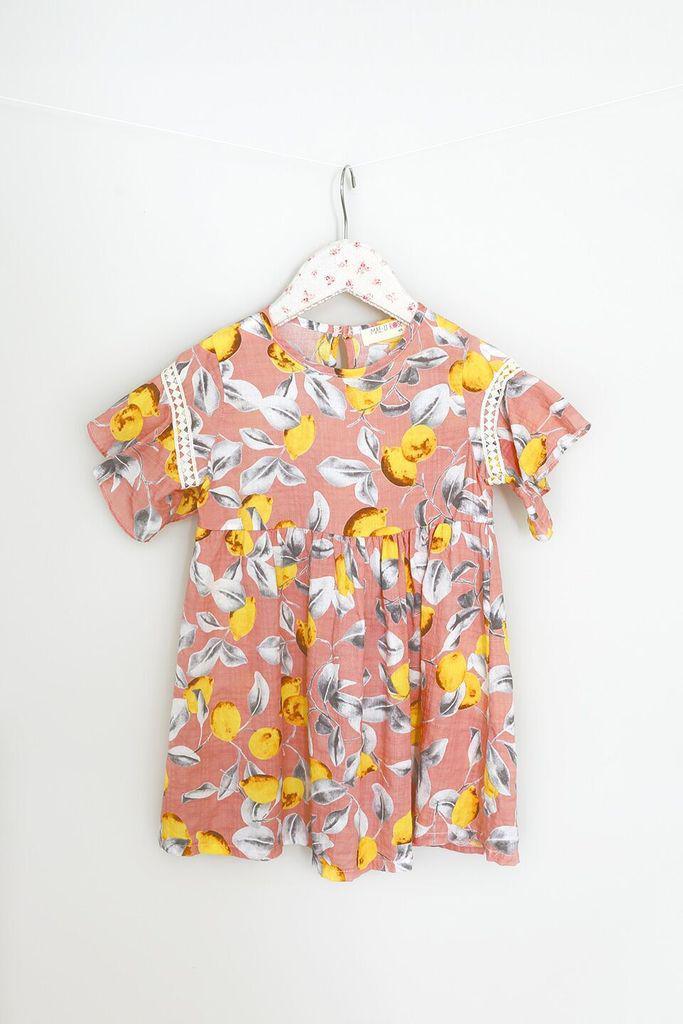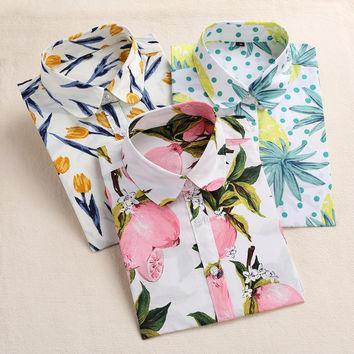The first image is the image on the left, the second image is the image on the right. Evaluate the accuracy of this statement regarding the images: "Each image contains a top with a printed pattern that includes pink fruits.". Is it true? Answer yes or no. No. The first image is the image on the left, the second image is the image on the right. Assess this claim about the two images: "One shirt is on a hanger.". Correct or not? Answer yes or no. Yes. 